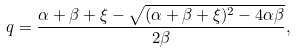Convert formula to latex. <formula><loc_0><loc_0><loc_500><loc_500>q = \frac { \alpha + \beta + \xi - \sqrt { ( \alpha + \beta + \xi ) ^ { 2 } - 4 \alpha \beta } } { 2 \beta } ,</formula> 